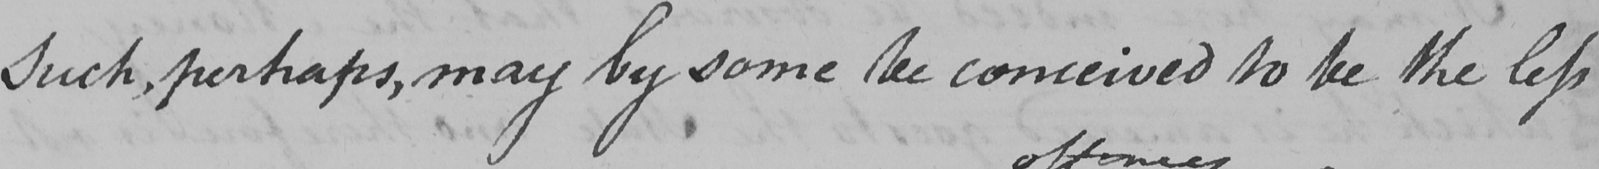Please transcribe the handwritten text in this image. Such , perhaps , may by some be conceived to be the less 